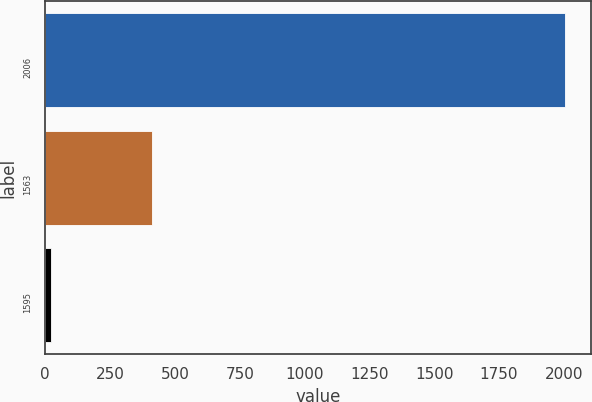Convert chart. <chart><loc_0><loc_0><loc_500><loc_500><bar_chart><fcel>2006<fcel>1563<fcel>1595<nl><fcel>2004<fcel>410<fcel>24<nl></chart> 